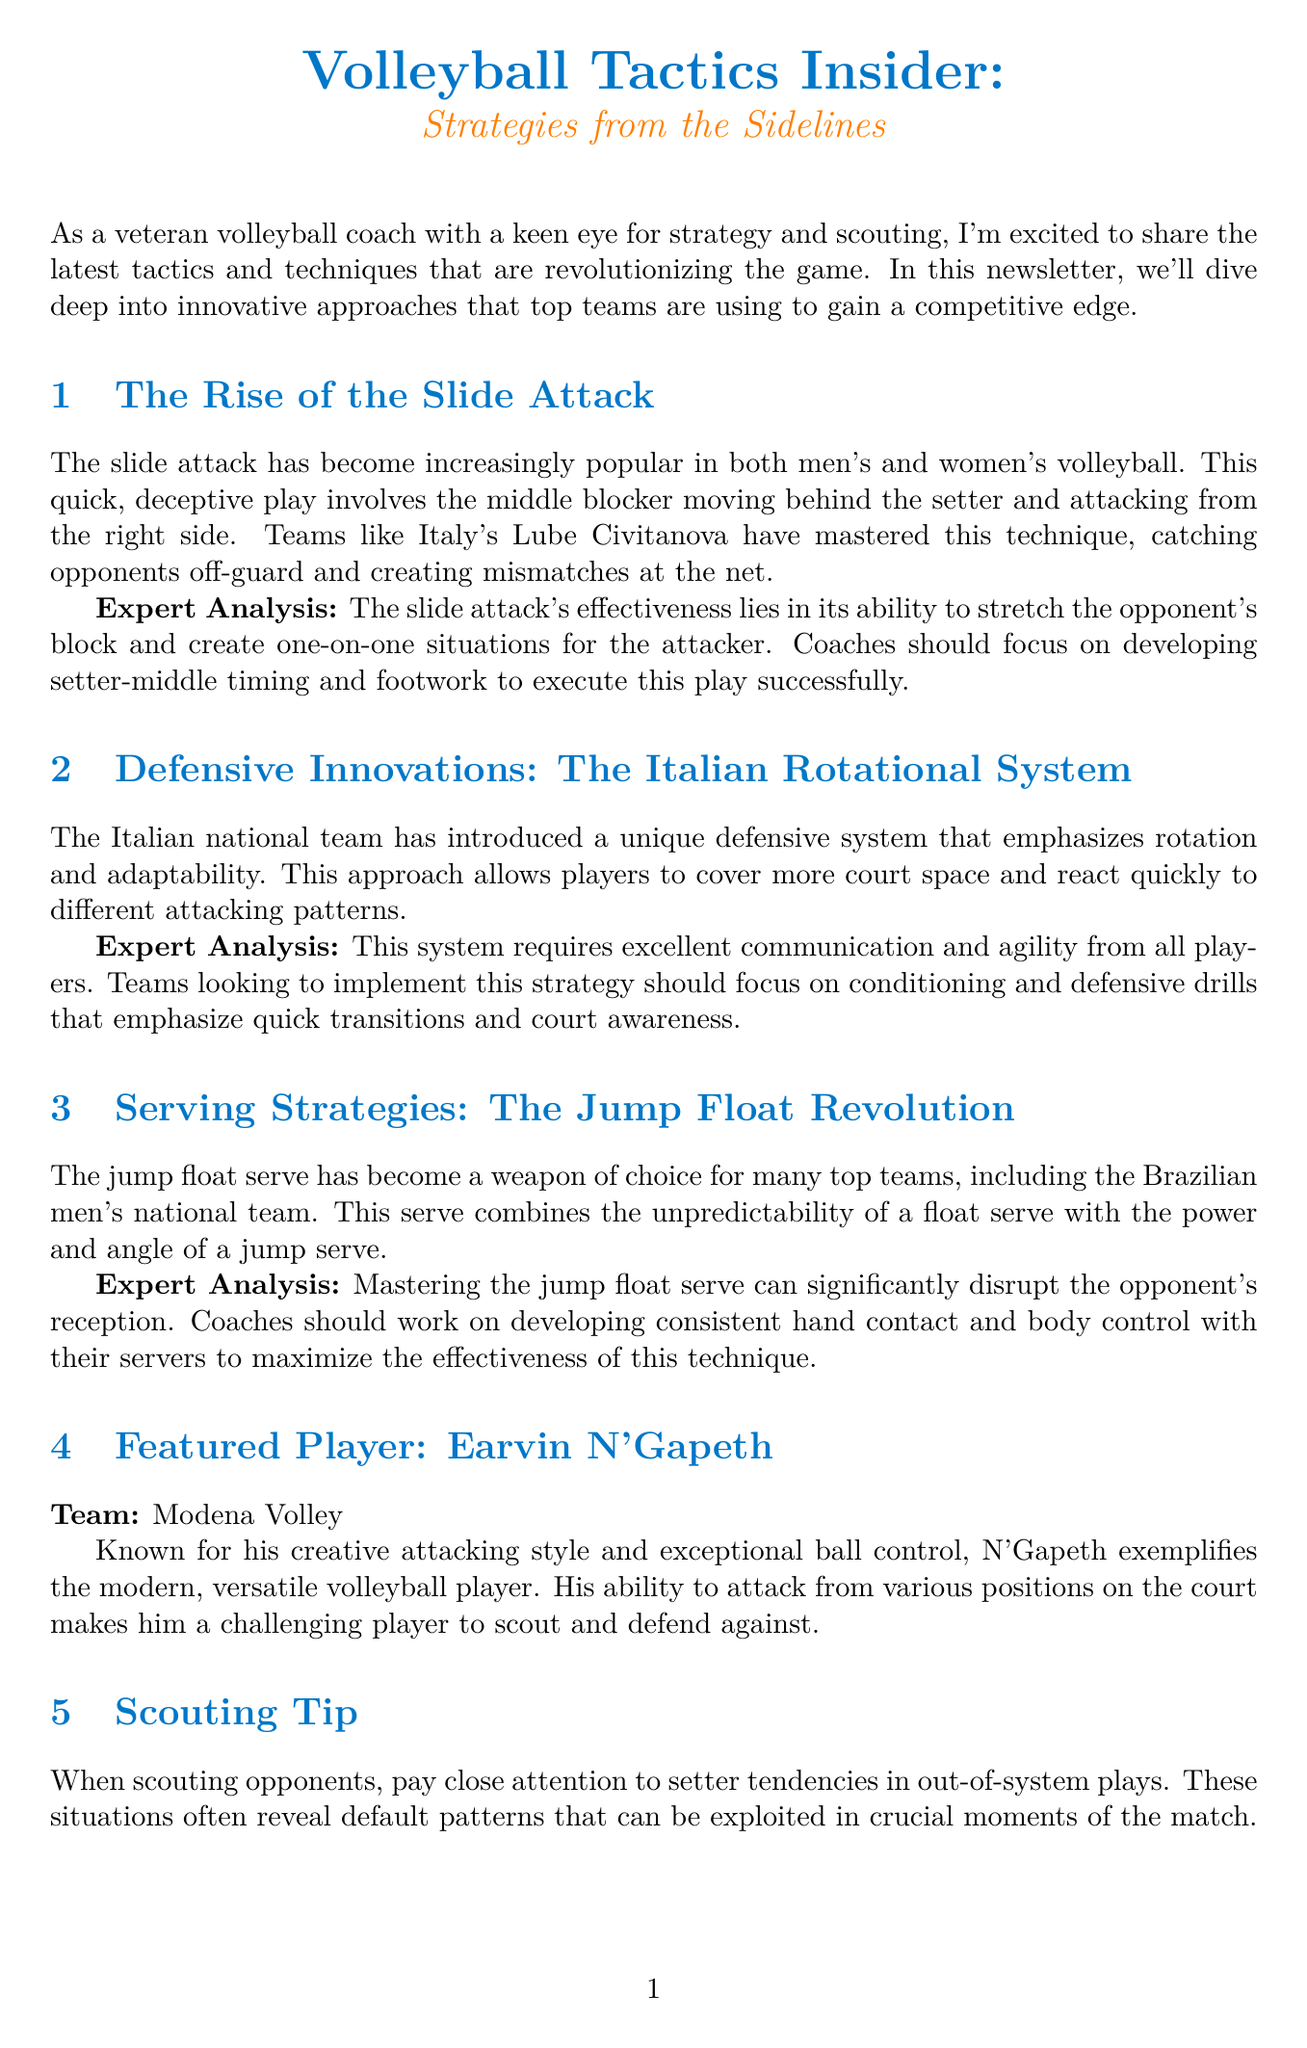What is the title of the newsletter? The title of the newsletter provides the main theme and focus, which is "Volleyball Tactics Insider: Strategies from the Sidelines."
Answer: Volleyball Tactics Insider: Strategies from the Sidelines What is one innovative attack strategy mentioned? The document discusses a specific innovative attack strategy that has gained popularity in volleyball, namely the 'slide attack.'
Answer: slide attack Who is the featured player in the newsletter? The featured player section highlights a prominent athlete in the sport, which in this case is Earvin N'Gapeth from Modena Volley.
Answer: Earvin N'Gapeth What is the name of the training drill described? The newsletter includes a specific training drill designed to improve certain skills, which is called "Multi-Ball Setter Decision Making."
Answer: Multi-Ball Setter Decision Making When does the FIVB Volleyball Nations League take place? The timing for this significant volleyball event is provided, occurring from May 31 to July 23, 2023.
Answer: May 31 - July 23, 2023 What is a key focus for teams using the Italian Rotational System? The Italian Rotational System emphasizes specific skills and drills, particularly communication and agility, to implement effectively.
Answer: communication and agility What impact does the jump float serve have on the game? The document explains that mastering the jump float serve can significantly affect the opponent’s ability to receive serves, contributing to its strategic importance.
Answer: disrupts opponent's reception How can coaches help players improve the slide attack? The newsletter suggests that to enhance the slide attack, coaches should concentrate on a particular aspect of training for the players.
Answer: developing setter-middle timing and footwork What event will take place in Turin, Italy? The document lists a specific sporting event that will happen in Turin, providing its name and date, which is the CEV Champions League Final, slated for May 20-21, 2023.
Answer: CEV Champions League Final 